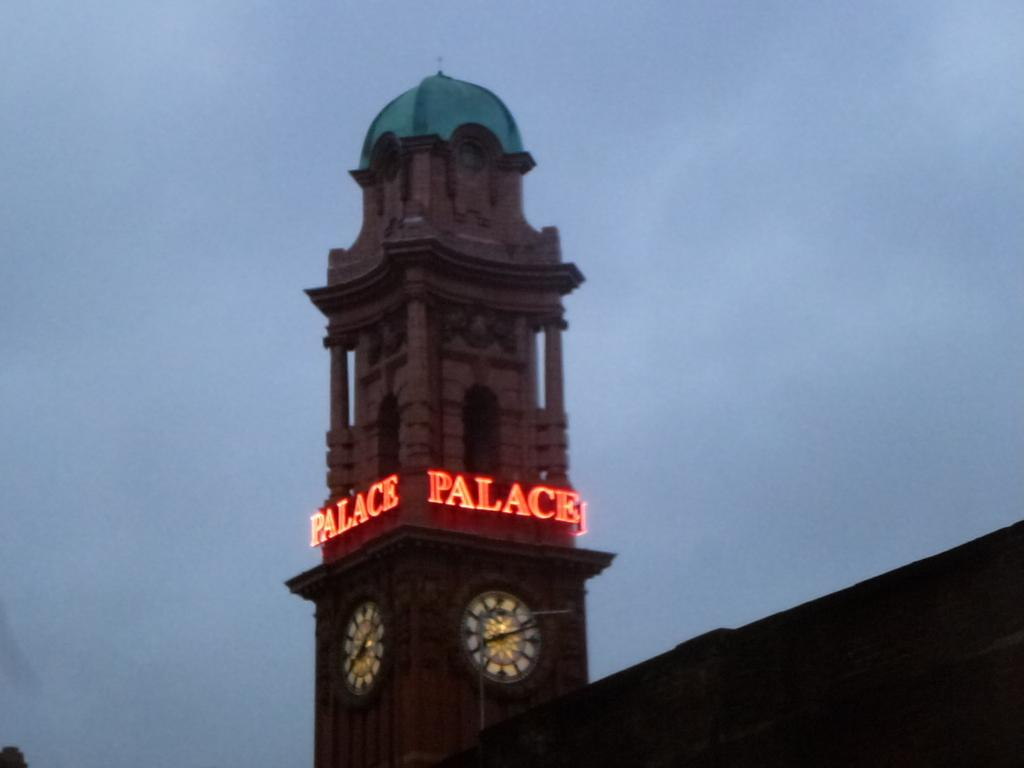<image>
Provide a brief description of the given image. Tall building with the words Palace on it. 